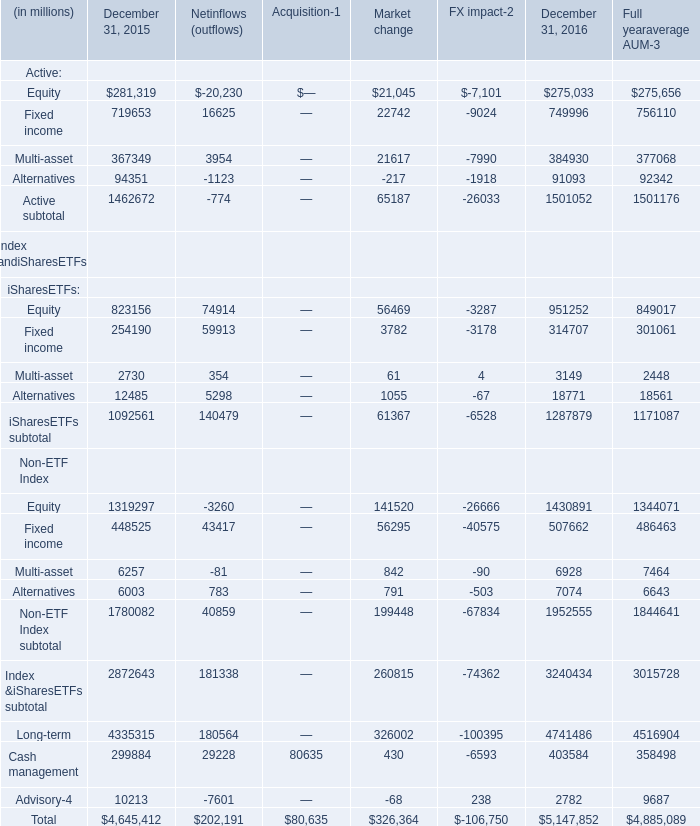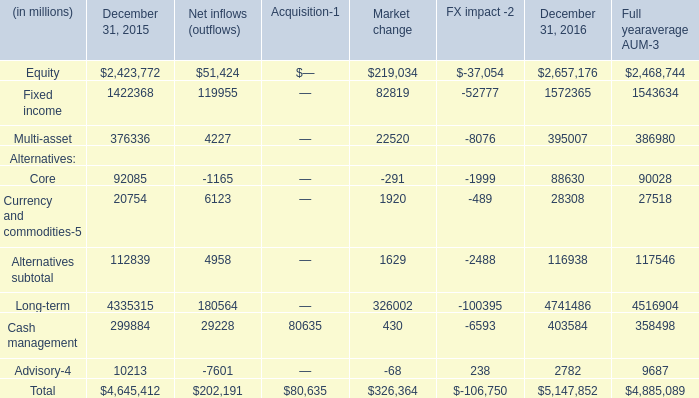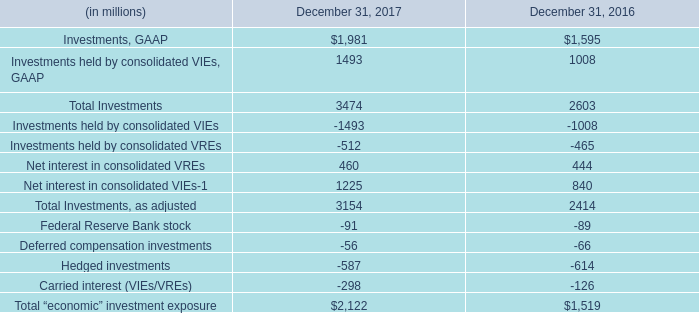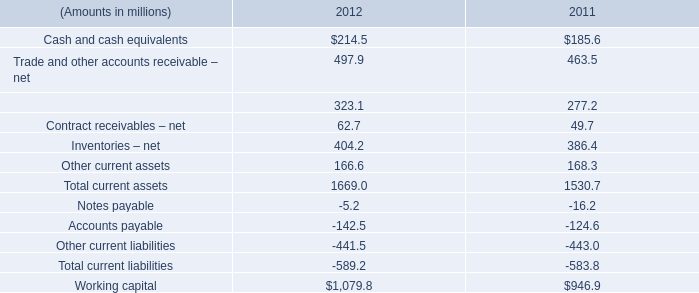How many Active: Fixed income exceed the average of Active: Fixed income in 2016? 
Answer: 2. 